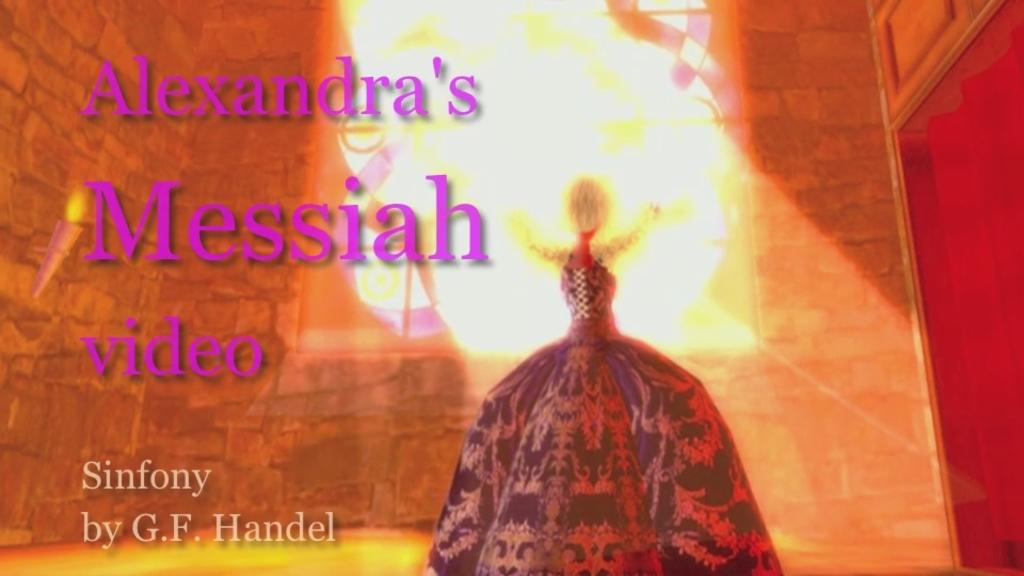<image>
Provide a brief description of the given image. A girl in a large dress is looking out a stained glass window and says Alexandra's Messiah video. 